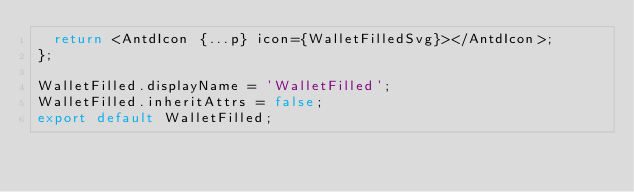<code> <loc_0><loc_0><loc_500><loc_500><_TypeScript_>  return <AntdIcon {...p} icon={WalletFilledSvg}></AntdIcon>;
};

WalletFilled.displayName = 'WalletFilled';
WalletFilled.inheritAttrs = false;
export default WalletFilled;</code> 